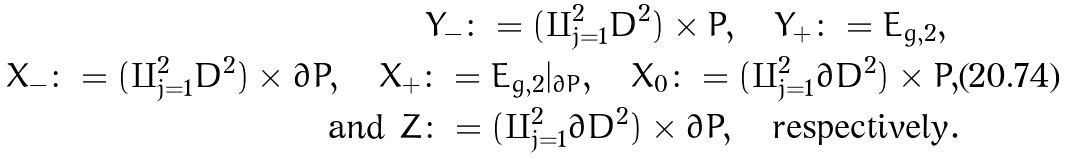Convert formula to latex. <formula><loc_0><loc_0><loc_500><loc_500>Y _ { - } \colon = ( \amalg _ { j = 1 } ^ { 2 } D ^ { 2 } ) \times P , \quad Y _ { + } \colon = E _ { g , 2 } , \ \\ X _ { - } \colon = ( \amalg _ { j = 1 } ^ { 2 } D ^ { 2 } ) \times \partial P , \quad X _ { + } \colon = E _ { g , 2 } | _ { \partial P } , \quad X _ { 0 } \colon = ( \amalg _ { j = 1 } ^ { 2 } \partial D ^ { 2 } ) \times P , \\ \text {and} \ Z \colon = ( \amalg _ { j = 1 } ^ { 2 } \partial D ^ { 2 } ) \times \partial P , \quad \text {respectively} .</formula> 